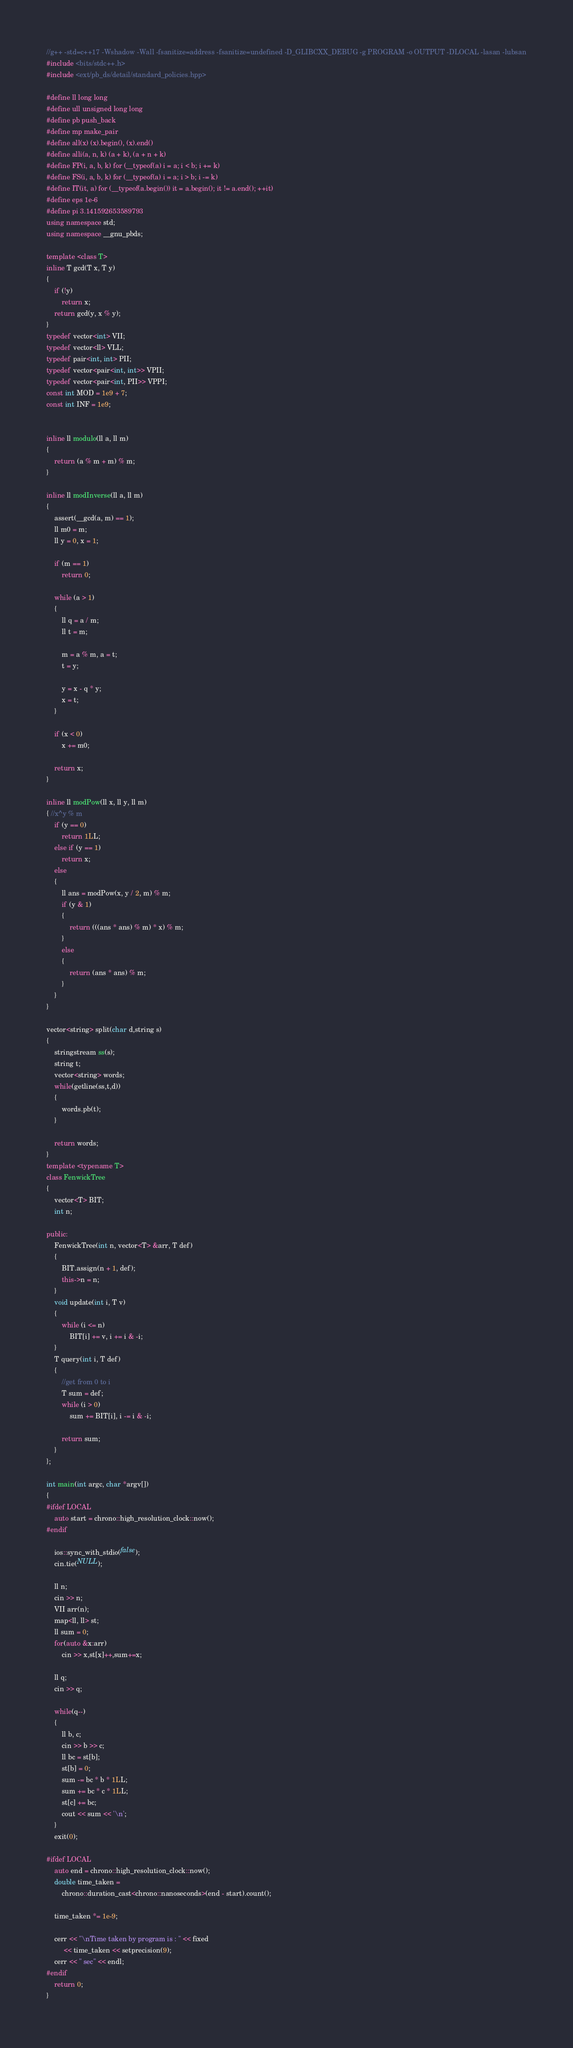<code> <loc_0><loc_0><loc_500><loc_500><_C++_>//g++ -std=c++17 -Wshadow -Wall -fsanitize=address -fsanitize=undefined -D_GLIBCXX_DEBUG -g PROGRAM -o OUTPUT -DLOCAL -lasan -lubsan
#include <bits/stdc++.h>
#include <ext/pb_ds/detail/standard_policies.hpp>

#define ll long long
#define ull unsigned long long
#define pb push_back
#define mp make_pair
#define all(x) (x).begin(), (x).end()
#define alli(a, n, k) (a + k), (a + n + k)
#define FP(i, a, b, k) for (__typeof(a) i = a; i < b; i += k)
#define FS(i, a, b, k) for (__typeof(a) i = a; i > b; i -= k)
#define IT(it, a) for (__typeof(a.begin()) it = a.begin(); it != a.end(); ++it)
#define eps 1e-6
#define pi 3.141592653589793
using namespace std;
using namespace __gnu_pbds;

template <class T>
inline T gcd(T x, T y)
{
    if (!y)
        return x;
    return gcd(y, x % y);
}
typedef vector<int> VII;
typedef vector<ll> VLL;
typedef pair<int, int> PII;
typedef vector<pair<int, int>> VPII;
typedef vector<pair<int, PII>> VPPI;
const int MOD = 1e9 + 7;
const int INF = 1e9;


inline ll modulo(ll a, ll m)
{
    return (a % m + m) % m;
}

inline ll modInverse(ll a, ll m)
{
    assert(__gcd(a, m) == 1);
    ll m0 = m;
    ll y = 0, x = 1;

    if (m == 1)
        return 0;

    while (a > 1)
    {
        ll q = a / m;
        ll t = m;

        m = a % m, a = t;
        t = y;

        y = x - q * y;
        x = t;
    }

    if (x < 0)
        x += m0;

    return x;
}

inline ll modPow(ll x, ll y, ll m)
{ //x^y % m
    if (y == 0)
        return 1LL;
    else if (y == 1)
        return x;
    else
    {
        ll ans = modPow(x, y / 2, m) % m;
        if (y & 1)
        {
            return (((ans * ans) % m) * x) % m;
        }
        else
        {
            return (ans * ans) % m;
        }
    }
}

vector<string> split(char d,string s)
{
    stringstream ss(s);
    string t;
    vector<string> words;
    while(getline(ss,t,d))
    {
        words.pb(t);
    }

    return words;
}
template <typename T>
class FenwickTree
{
    vector<T> BIT;
    int n;

public:
    FenwickTree(int n, vector<T> &arr, T def)
    {
        BIT.assign(n + 1, def);
        this->n = n;
    }
    void update(int i, T v)
    {
        while (i <= n)
            BIT[i] += v, i += i & -i;
    }
    T query(int i, T def)
    {
        //get from 0 to i
        T sum = def;
        while (i > 0)
            sum += BIT[i], i -= i & -i;

        return sum;
    }
};

int main(int argc, char *argv[])
{
#ifdef LOCAL
    auto start = chrono::high_resolution_clock::now();
#endif
    
    ios::sync_with_stdio(false);
    cin.tie(NULL);

    ll n;
    cin >> n;
    VII arr(n);
    map<ll, ll> st;
    ll sum = 0;
    for(auto &x:arr)
        cin >> x,st[x]++,sum+=x;

    ll q;
    cin >> q;

    while(q--)
    {
        ll b, c;
        cin >> b >> c;
        ll bc = st[b];
        st[b] = 0;
        sum -= bc * b * 1LL;
        sum += bc * c * 1LL;
        st[c] += bc;
        cout << sum << '\n';
    }
    exit(0);

#ifdef LOCAL
    auto end = chrono::high_resolution_clock::now();
    double time_taken =
        chrono::duration_cast<chrono::nanoseconds>(end - start).count();

    time_taken *= 1e-9;

    cerr << "\nTime taken by program is : " << fixed
         << time_taken << setprecision(9);
    cerr << " sec" << endl;
#endif
    return 0;
}
</code> 